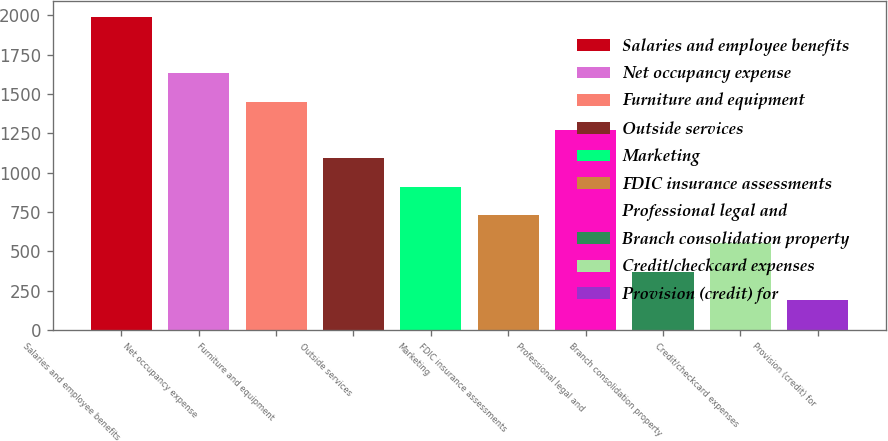Convert chart to OTSL. <chart><loc_0><loc_0><loc_500><loc_500><bar_chart><fcel>Salaries and employee benefits<fcel>Net occupancy expense<fcel>Furniture and equipment<fcel>Outside services<fcel>Marketing<fcel>FDIC insurance assessments<fcel>Professional legal and<fcel>Branch consolidation property<fcel>Credit/checkcard expenses<fcel>Provision (credit) for<nl><fcel>1989.8<fcel>1630.2<fcel>1450.4<fcel>1090.8<fcel>911<fcel>731.2<fcel>1270.6<fcel>371.6<fcel>551.4<fcel>191.8<nl></chart> 